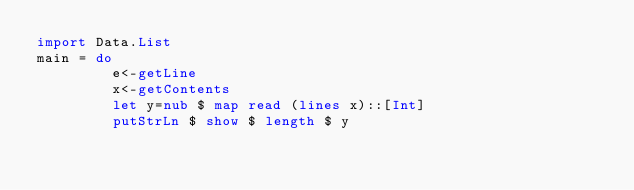<code> <loc_0><loc_0><loc_500><loc_500><_Haskell_>import Data.List
main = do
         e<-getLine
         x<-getContents
         let y=nub $ map read (lines x)::[Int]
         putStrLn $ show $ length $ y</code> 